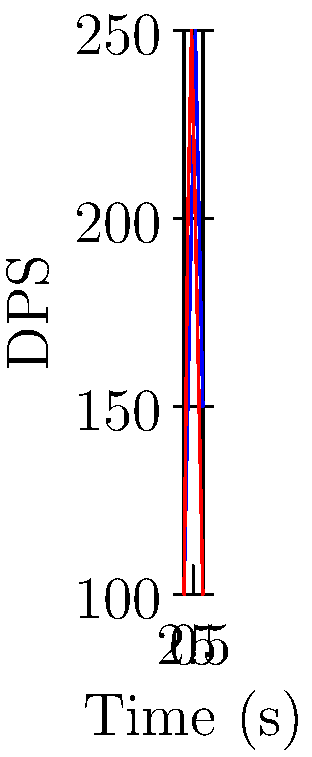Given the DPS output graphs for two different skill rotations (A and B) over a 5-second period, determine the group action that transforms Rotation A into Rotation B. What is the order of this group action? To solve this problem, we need to analyze the relationship between the two DPS output graphs and identify the transformation that maps Rotation A to Rotation B. Let's approach this step-by-step:

1. Observe the graphs:
   - Rotation A: Starts at 100, peaks at 250 at t=3, then decreases
   - Rotation B: Starts at 100, peaks at 250 at t=2, then decreases

2. Identify the transformation:
   The graph of Rotation B appears to be a horizontal reflection of Rotation A about the line t=2.5.

3. Express the transformation mathematically:
   If we denote the time as t and the reflection line as t=a, the transformation can be expressed as:
   $f(t) = 2a - t$
   In this case, a = 2.5, so $f(t) = 5 - t$

4. Verify the group properties:
   - Closure: Applying this transformation twice returns the original graph
   - Associativity: Holds for function composition
   - Identity: The identity transformation (no change) exists
   - Inverse: The transformation is its own inverse

5. Determine the order of the group action:
   The order of a group action is the smallest positive integer n such that $f^n(t) = t$
   In this case, $f(f(t)) = f(5-t) = 5-(5-t) = t$
   Therefore, the order of this group action is 2.
Answer: Horizontal reflection; order 2 